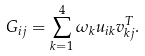<formula> <loc_0><loc_0><loc_500><loc_500>G _ { i j } = \sum _ { k = 1 } ^ { 4 } \omega _ { k } u _ { i k } v _ { k j } ^ { T } .</formula> 